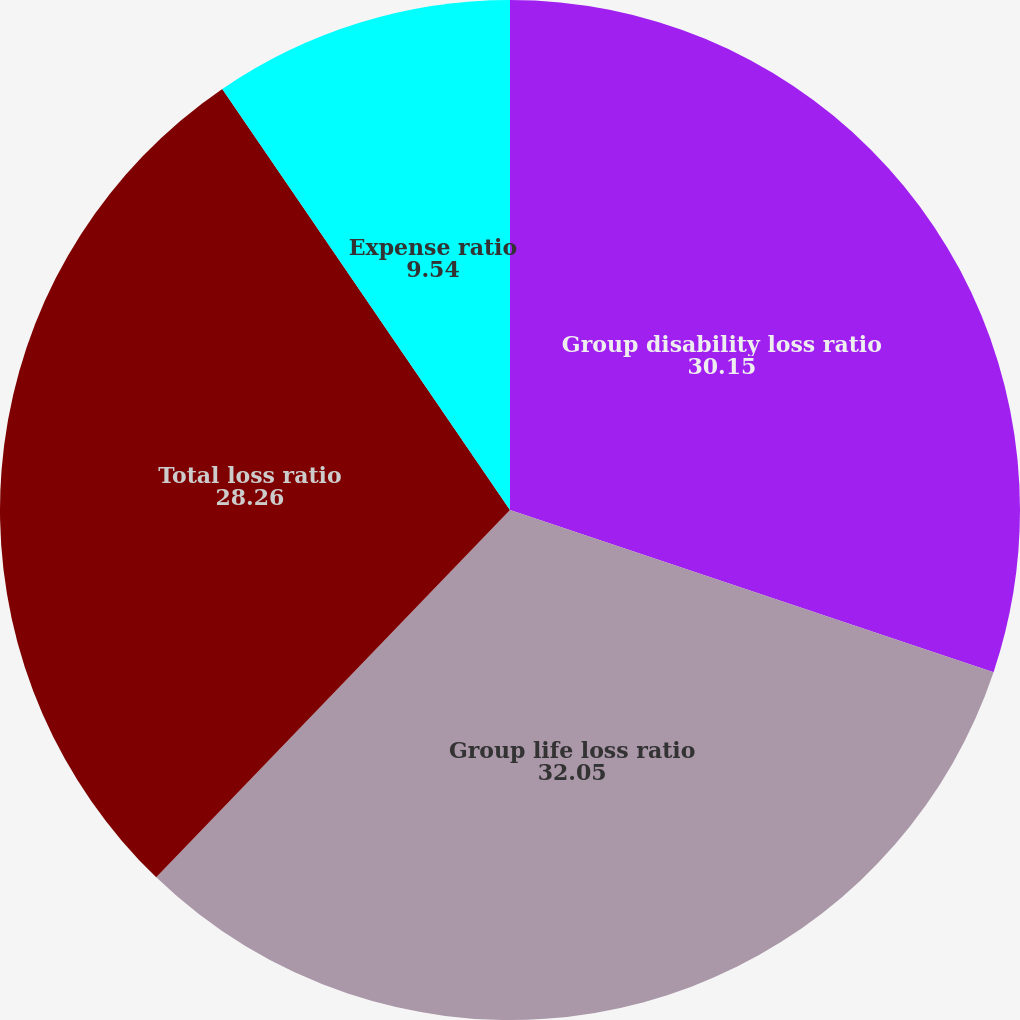Convert chart to OTSL. <chart><loc_0><loc_0><loc_500><loc_500><pie_chart><fcel>Group disability loss ratio<fcel>Group life loss ratio<fcel>Total loss ratio<fcel>Expense ratio<nl><fcel>30.15%<fcel>32.05%<fcel>28.26%<fcel>9.54%<nl></chart> 